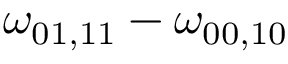Convert formula to latex. <formula><loc_0><loc_0><loc_500><loc_500>\omega _ { 0 1 , 1 1 } - \omega _ { 0 0 , 1 0 }</formula> 